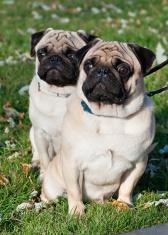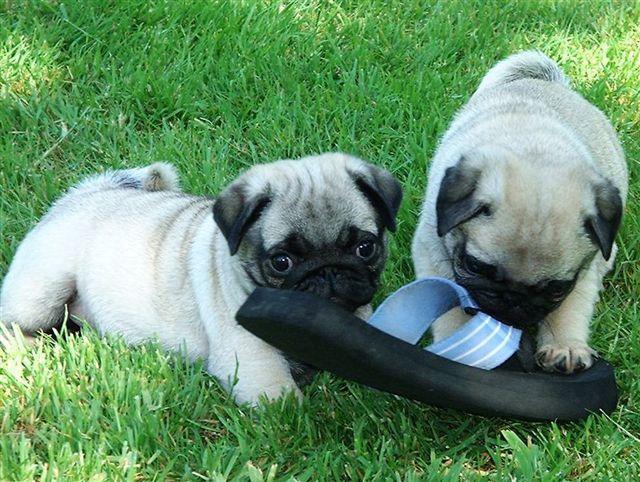The first image is the image on the left, the second image is the image on the right. Given the left and right images, does the statement "All the images show pugs that are tan." hold true? Answer yes or no. Yes. The first image is the image on the left, the second image is the image on the right. Considering the images on both sides, is "There is a toy present with two dogs." valid? Answer yes or no. Yes. 